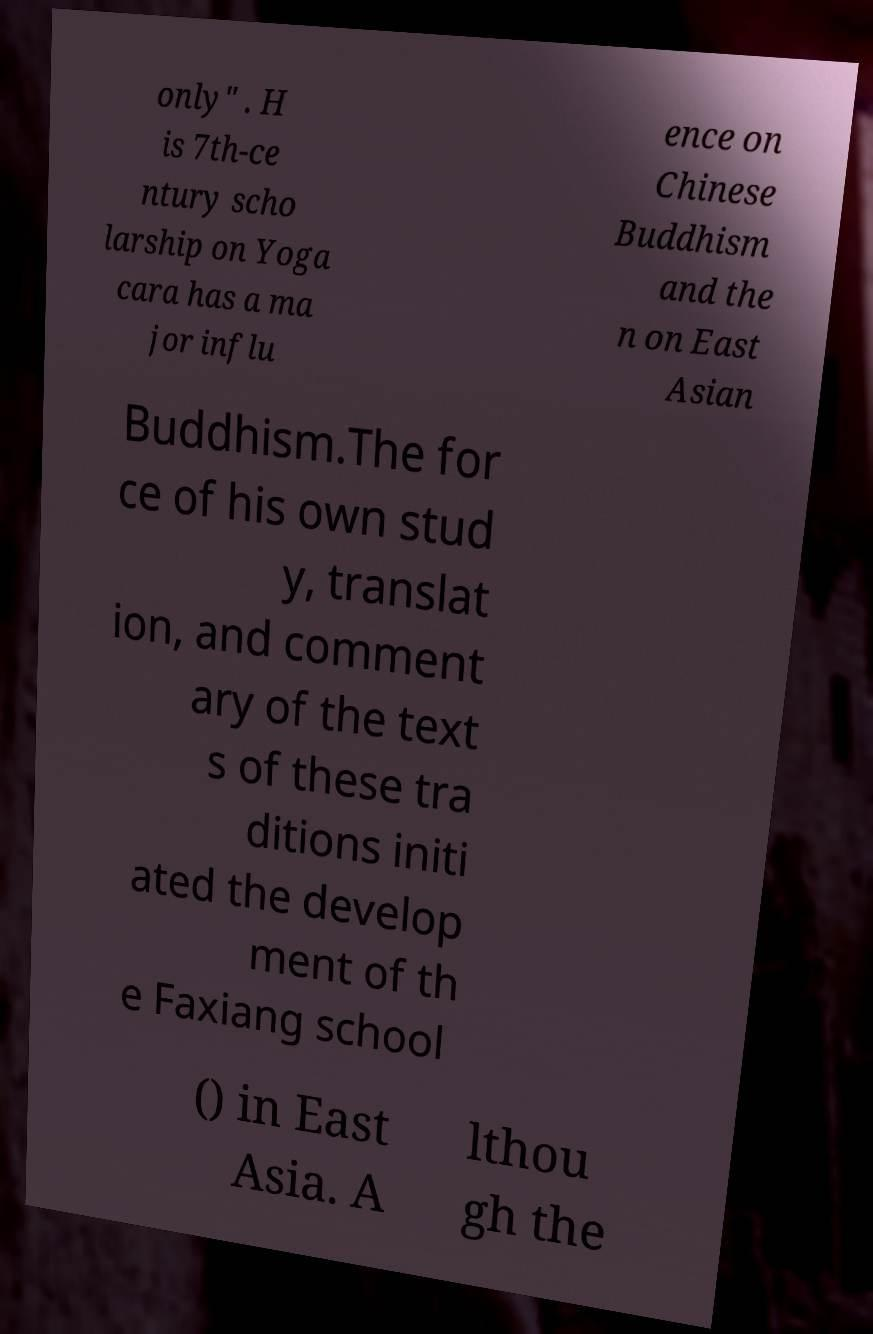Please identify and transcribe the text found in this image. only" . H is 7th-ce ntury scho larship on Yoga cara has a ma jor influ ence on Chinese Buddhism and the n on East Asian Buddhism.The for ce of his own stud y, translat ion, and comment ary of the text s of these tra ditions initi ated the develop ment of th e Faxiang school () in East Asia. A lthou gh the 